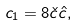Convert formula to latex. <formula><loc_0><loc_0><loc_500><loc_500>c _ { 1 } = 8 \check { c } \hat { c } ,</formula> 